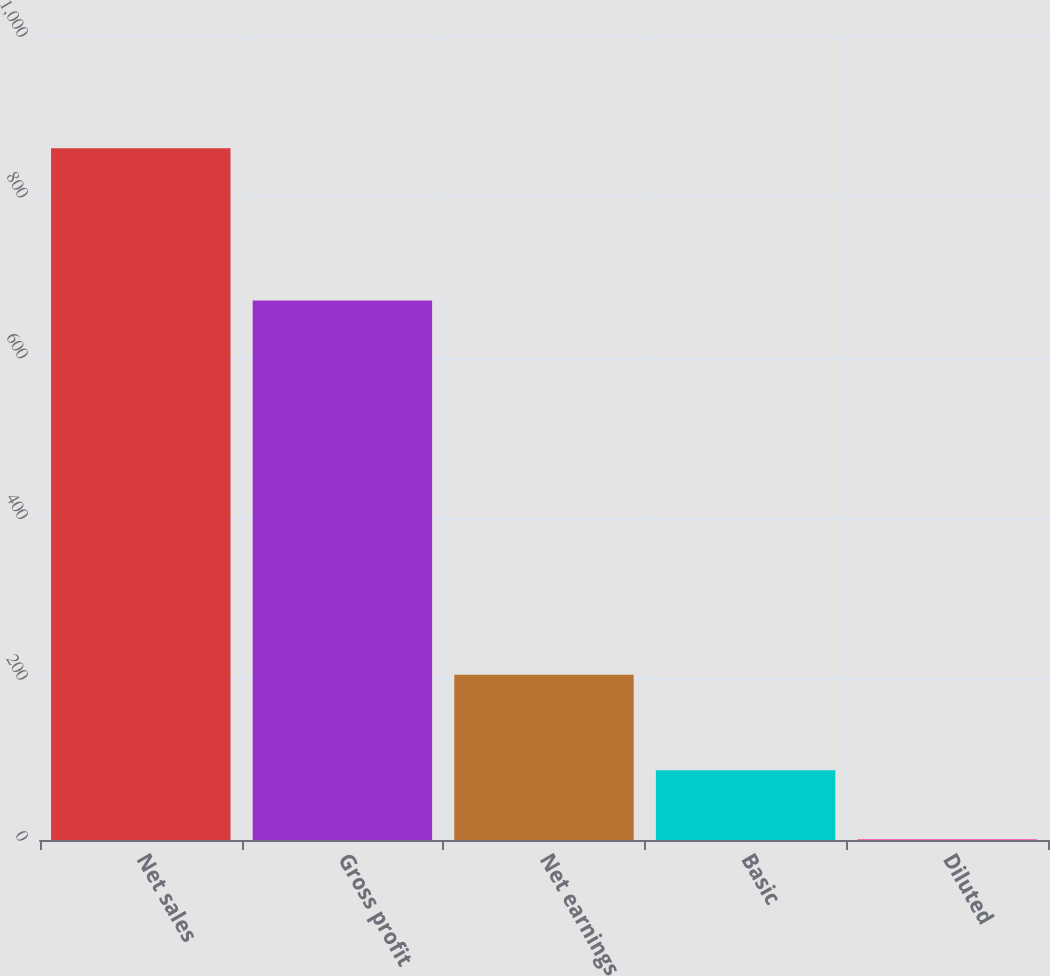Convert chart to OTSL. <chart><loc_0><loc_0><loc_500><loc_500><bar_chart><fcel>Net sales<fcel>Gross profit<fcel>Net earnings<fcel>Basic<fcel>Diluted<nl><fcel>860.4<fcel>671<fcel>205.6<fcel>86.78<fcel>0.82<nl></chart> 